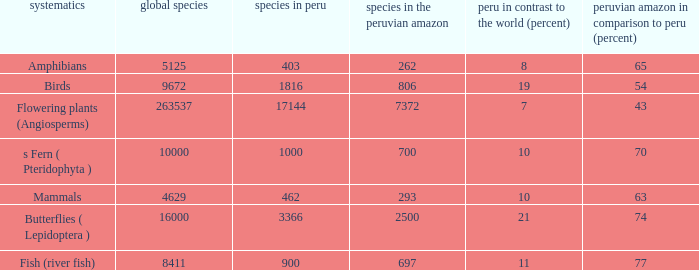What's the species in the world with peruvian amazon vs. peru (percent)  of 63 4629.0. 